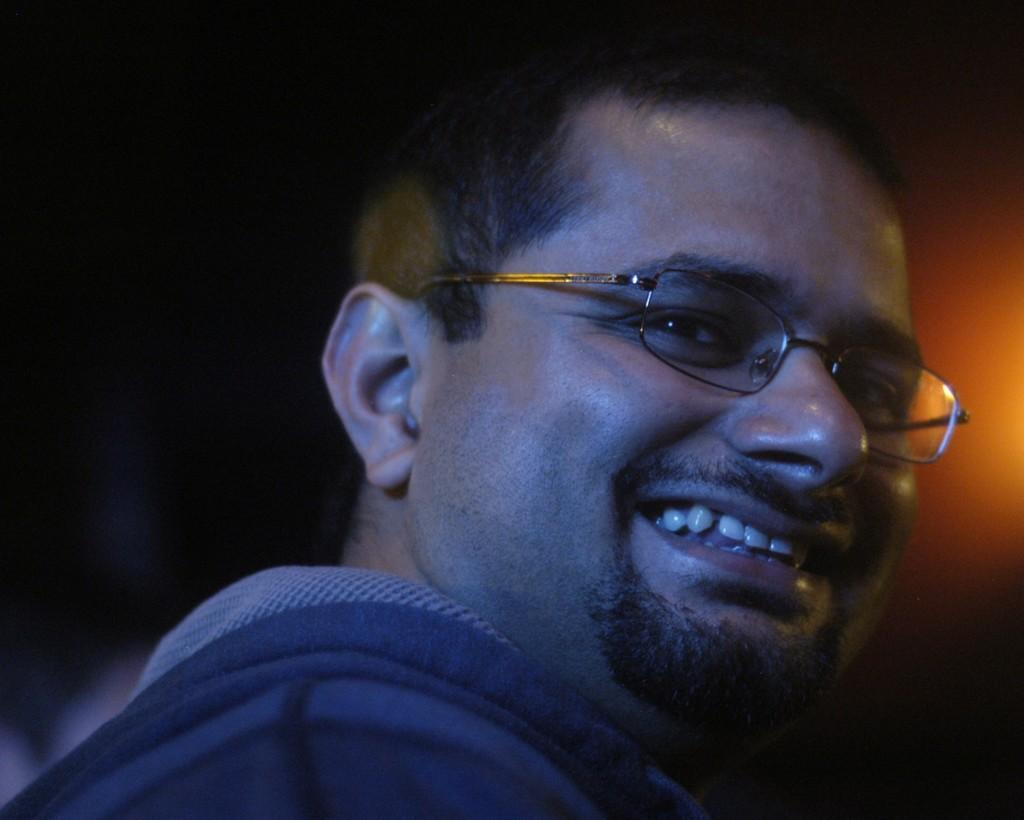What is the main subject of the image? There is a close-up picture of a man in the image. What can be observed about the man's attire? The man is wearing clothes. Are there any accessories visible on the man? Yes, the man is wearing spectacles. What is the man's facial expression in the image? The man is smiling. How would you describe the background of the image? The background of the image is dark. What type of glove is the man wearing in the image? There is no glove visible in the image; the man is wearing spectacles. How is the blade being distributed in the image? There is no blade present in the image. 